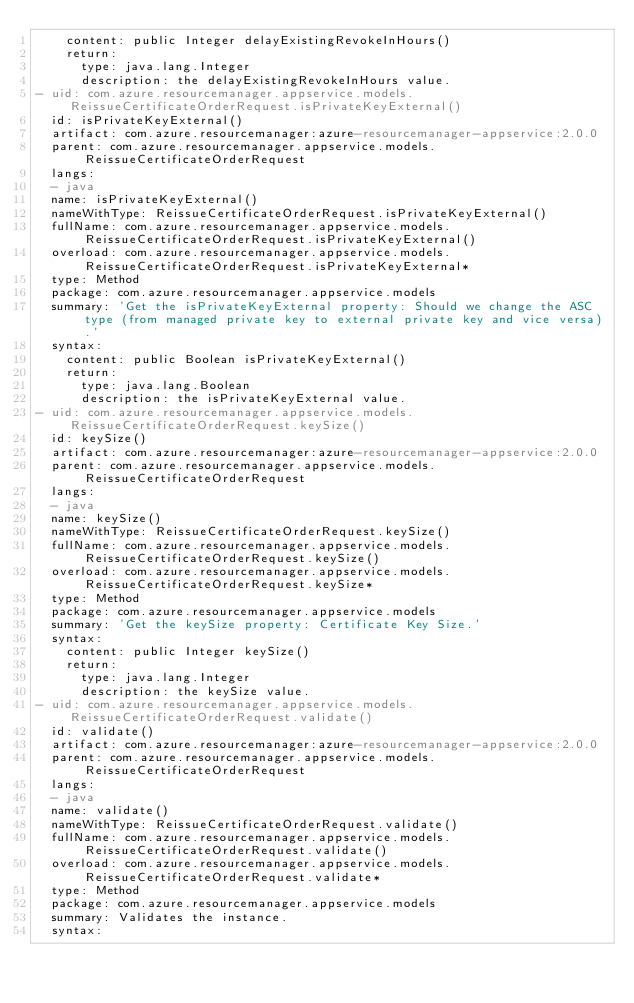<code> <loc_0><loc_0><loc_500><loc_500><_YAML_>    content: public Integer delayExistingRevokeInHours()
    return:
      type: java.lang.Integer
      description: the delayExistingRevokeInHours value.
- uid: com.azure.resourcemanager.appservice.models.ReissueCertificateOrderRequest.isPrivateKeyExternal()
  id: isPrivateKeyExternal()
  artifact: com.azure.resourcemanager:azure-resourcemanager-appservice:2.0.0
  parent: com.azure.resourcemanager.appservice.models.ReissueCertificateOrderRequest
  langs:
  - java
  name: isPrivateKeyExternal()
  nameWithType: ReissueCertificateOrderRequest.isPrivateKeyExternal()
  fullName: com.azure.resourcemanager.appservice.models.ReissueCertificateOrderRequest.isPrivateKeyExternal()
  overload: com.azure.resourcemanager.appservice.models.ReissueCertificateOrderRequest.isPrivateKeyExternal*
  type: Method
  package: com.azure.resourcemanager.appservice.models
  summary: 'Get the isPrivateKeyExternal property: Should we change the ASC type (from managed private key to external private key and vice versa).'
  syntax:
    content: public Boolean isPrivateKeyExternal()
    return:
      type: java.lang.Boolean
      description: the isPrivateKeyExternal value.
- uid: com.azure.resourcemanager.appservice.models.ReissueCertificateOrderRequest.keySize()
  id: keySize()
  artifact: com.azure.resourcemanager:azure-resourcemanager-appservice:2.0.0
  parent: com.azure.resourcemanager.appservice.models.ReissueCertificateOrderRequest
  langs:
  - java
  name: keySize()
  nameWithType: ReissueCertificateOrderRequest.keySize()
  fullName: com.azure.resourcemanager.appservice.models.ReissueCertificateOrderRequest.keySize()
  overload: com.azure.resourcemanager.appservice.models.ReissueCertificateOrderRequest.keySize*
  type: Method
  package: com.azure.resourcemanager.appservice.models
  summary: 'Get the keySize property: Certificate Key Size.'
  syntax:
    content: public Integer keySize()
    return:
      type: java.lang.Integer
      description: the keySize value.
- uid: com.azure.resourcemanager.appservice.models.ReissueCertificateOrderRequest.validate()
  id: validate()
  artifact: com.azure.resourcemanager:azure-resourcemanager-appservice:2.0.0
  parent: com.azure.resourcemanager.appservice.models.ReissueCertificateOrderRequest
  langs:
  - java
  name: validate()
  nameWithType: ReissueCertificateOrderRequest.validate()
  fullName: com.azure.resourcemanager.appservice.models.ReissueCertificateOrderRequest.validate()
  overload: com.azure.resourcemanager.appservice.models.ReissueCertificateOrderRequest.validate*
  type: Method
  package: com.azure.resourcemanager.appservice.models
  summary: Validates the instance.
  syntax:</code> 